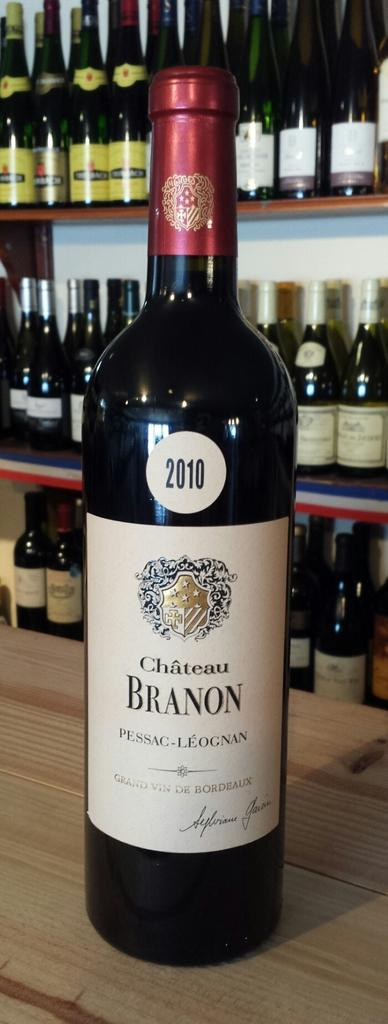<image>
Share a concise interpretation of the image provided. A bottle of Chateau Branon sits on a wooden bar. 